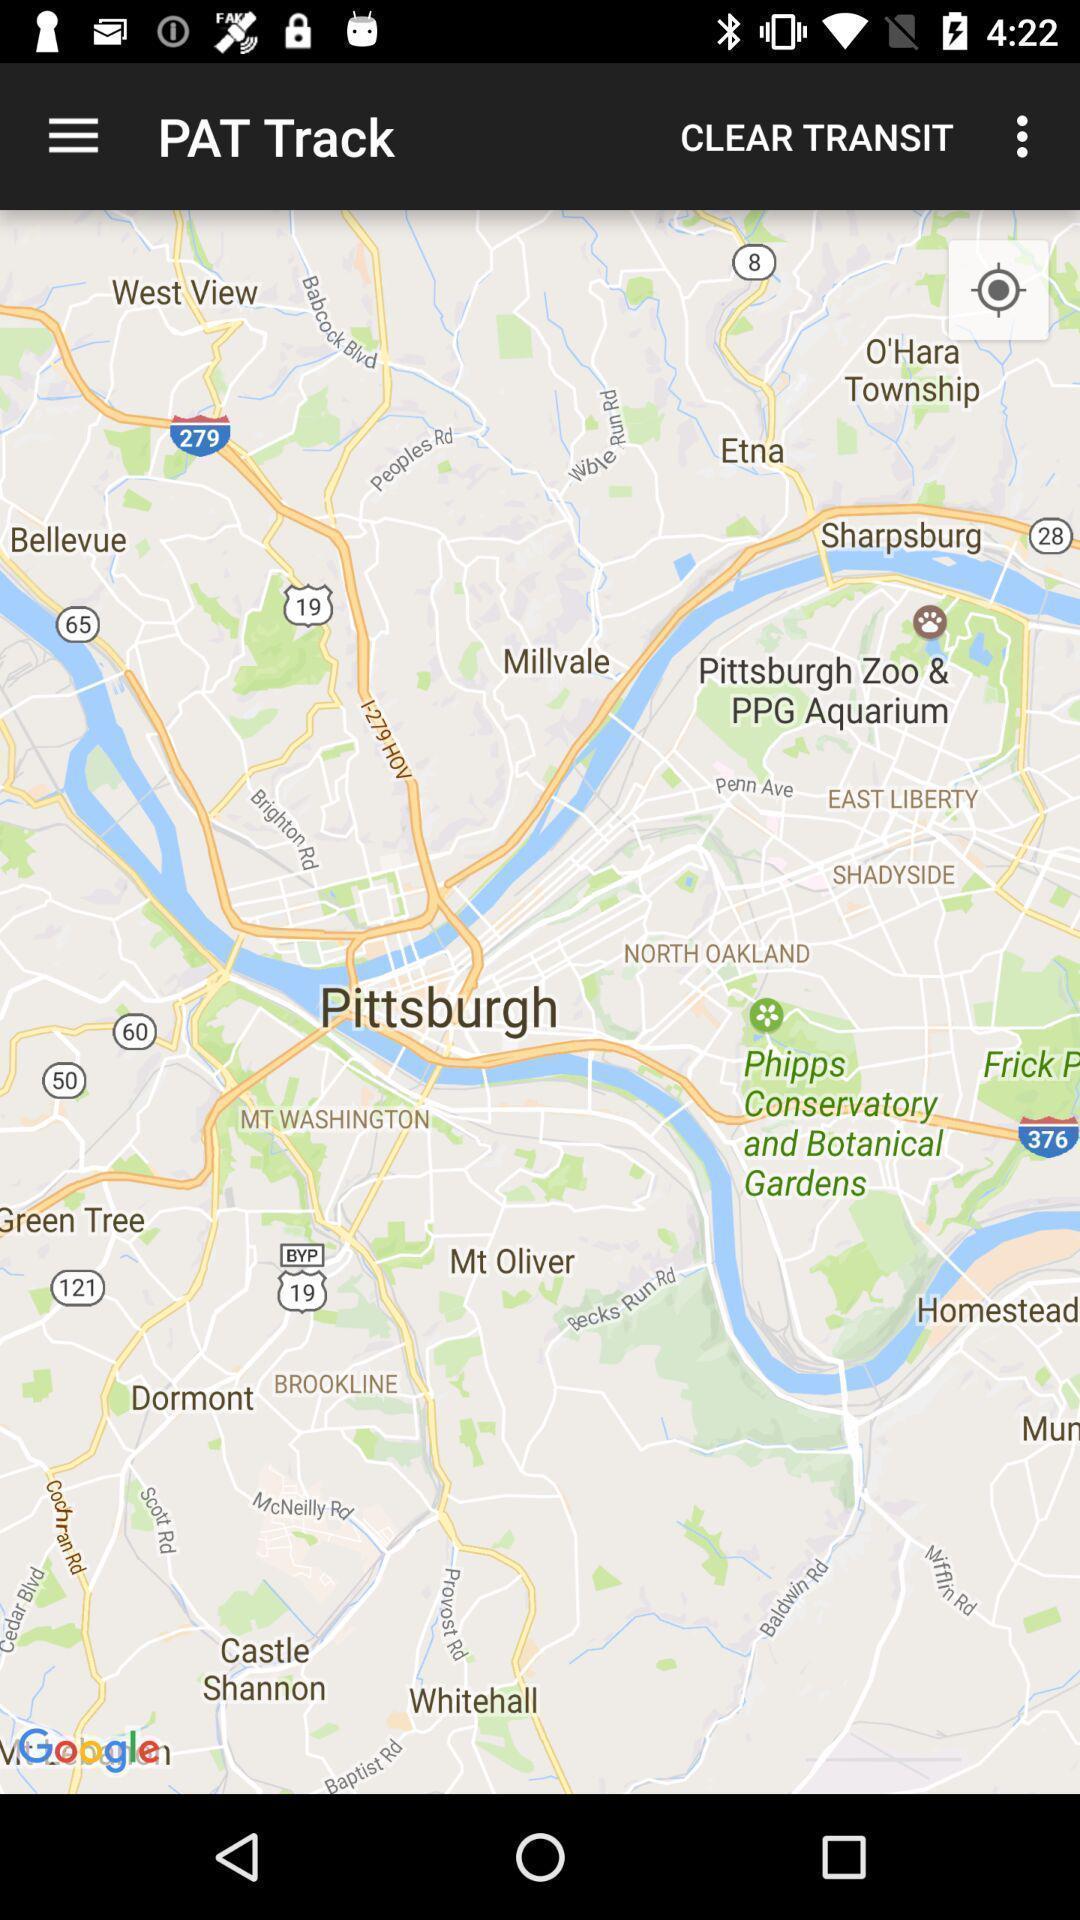What is the overall content of this screenshot? Page showing track details in app. 